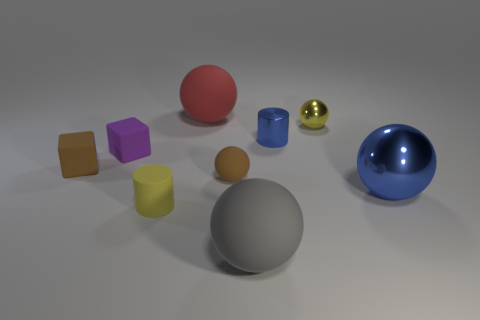Subtract all yellow metallic spheres. How many spheres are left? 4 Add 1 small metallic cylinders. How many objects exist? 10 Subtract 0 yellow blocks. How many objects are left? 9 Subtract all cubes. How many objects are left? 7 Subtract all red spheres. Subtract all brown cylinders. How many spheres are left? 4 Subtract all tiny blue cylinders. Subtract all large gray matte spheres. How many objects are left? 7 Add 5 gray rubber things. How many gray rubber things are left? 6 Add 1 large metal spheres. How many large metal spheres exist? 2 Subtract all blue balls. How many balls are left? 4 